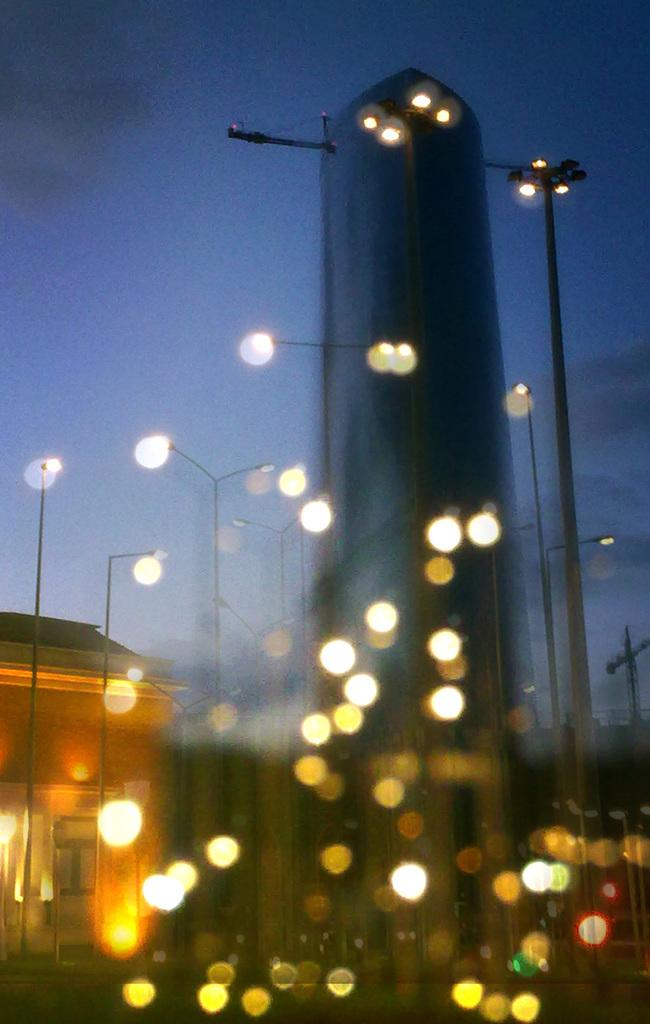What type of structure is present in the image? There is a house in the image. What other objects can be seen in the image? There are poles and lights visible in the image. What is visible in the background of the image? The sky is visible in the background of the image. What type of ink is being used to write on the dinner table in the image? There is no ink or dinner table present in the image. What emotion is being displayed by the house in the image? The image does not depict emotions, as it is a photograph of a house, poles, lights, and the sky. 